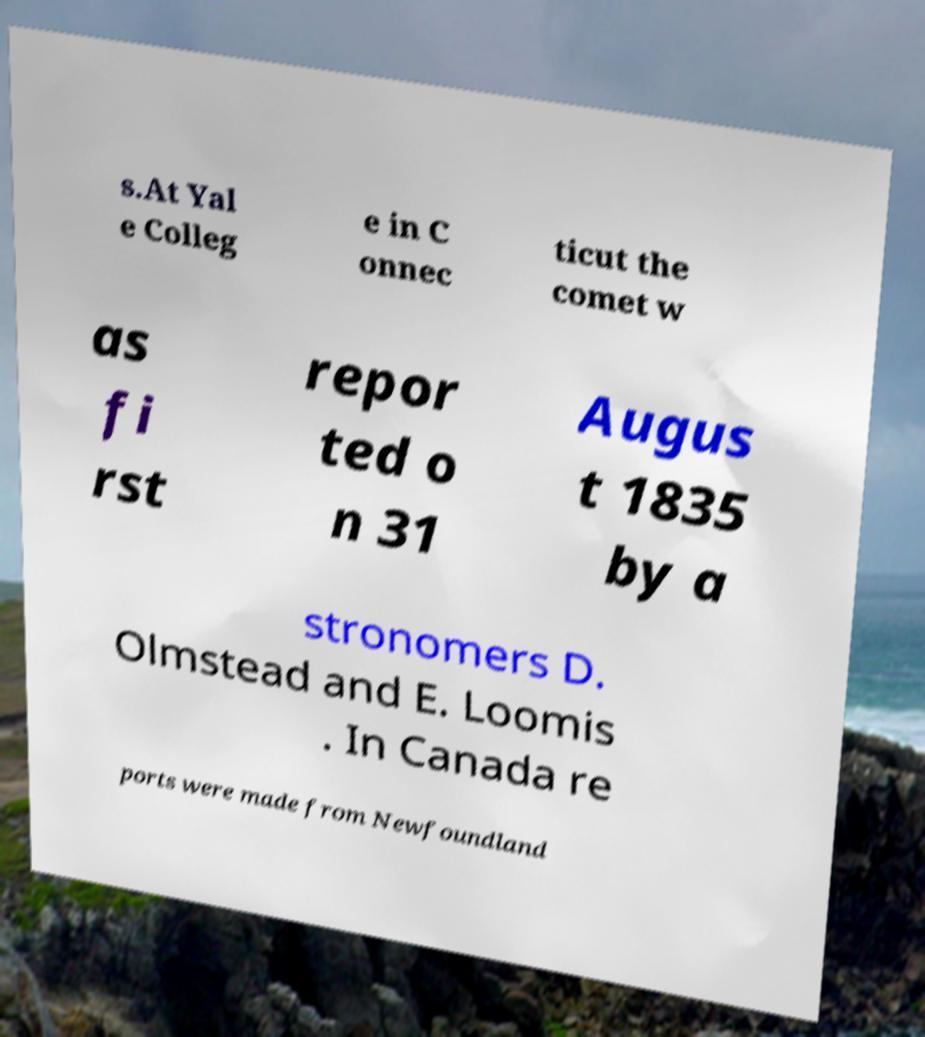Please read and relay the text visible in this image. What does it say? s.At Yal e Colleg e in C onnec ticut the comet w as fi rst repor ted o n 31 Augus t 1835 by a stronomers D. Olmstead and E. Loomis . In Canada re ports were made from Newfoundland 